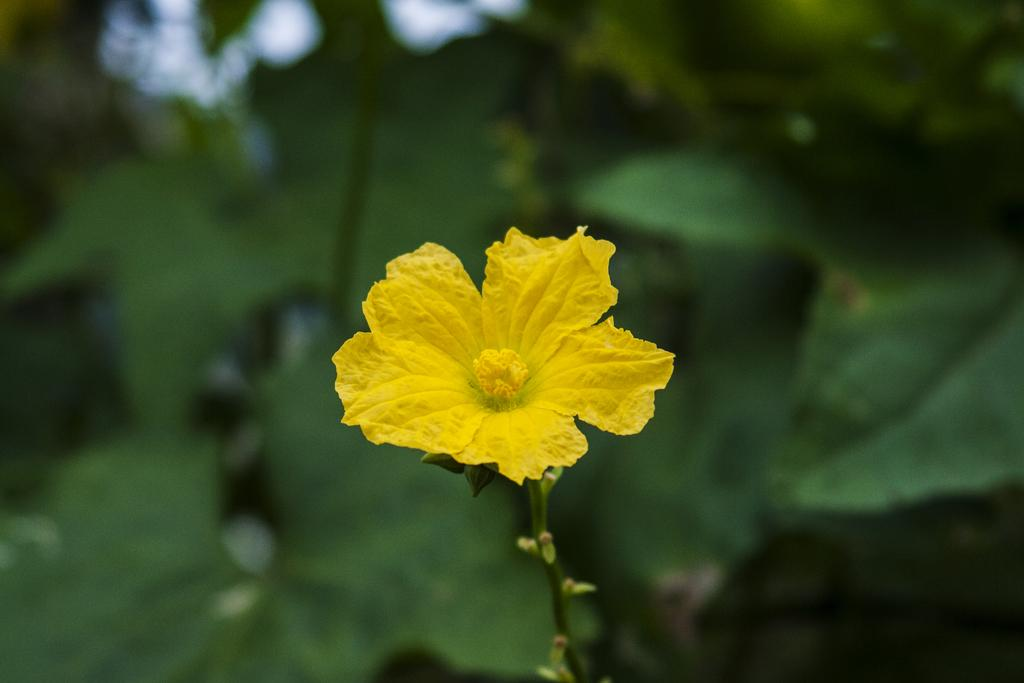What is the main subject of the image? There is a flower in the image. Can you describe the background of the image? The background of the image is blurred. What type of drum is being played in the background of the image? There is no drum present in the image; it only features a flower and a blurred background. 